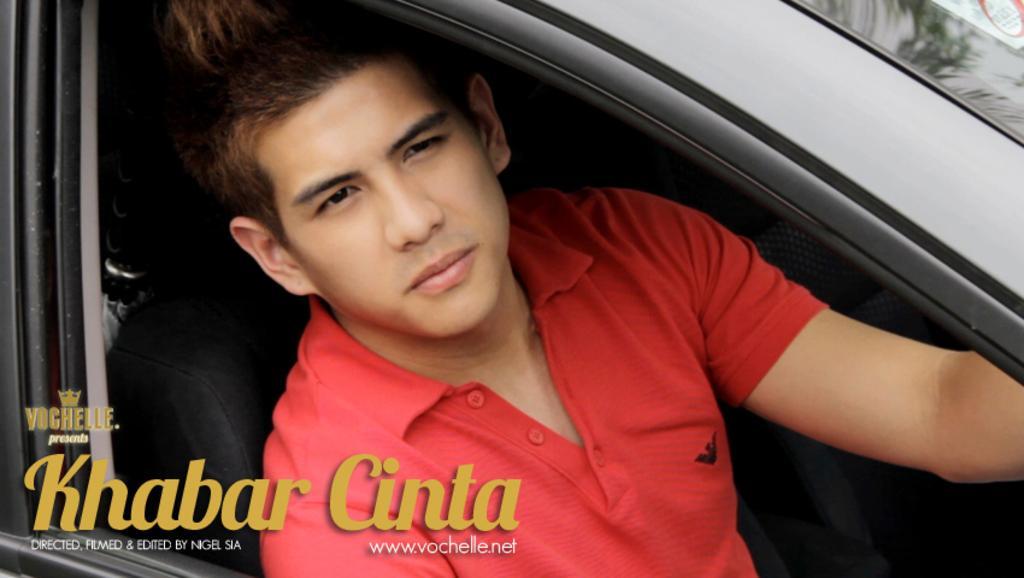How would you summarize this image in a sentence or two? In this picture i could see a person sitting inside the car, the seat is black in color and car looks black and person is wearing red t shirt. 